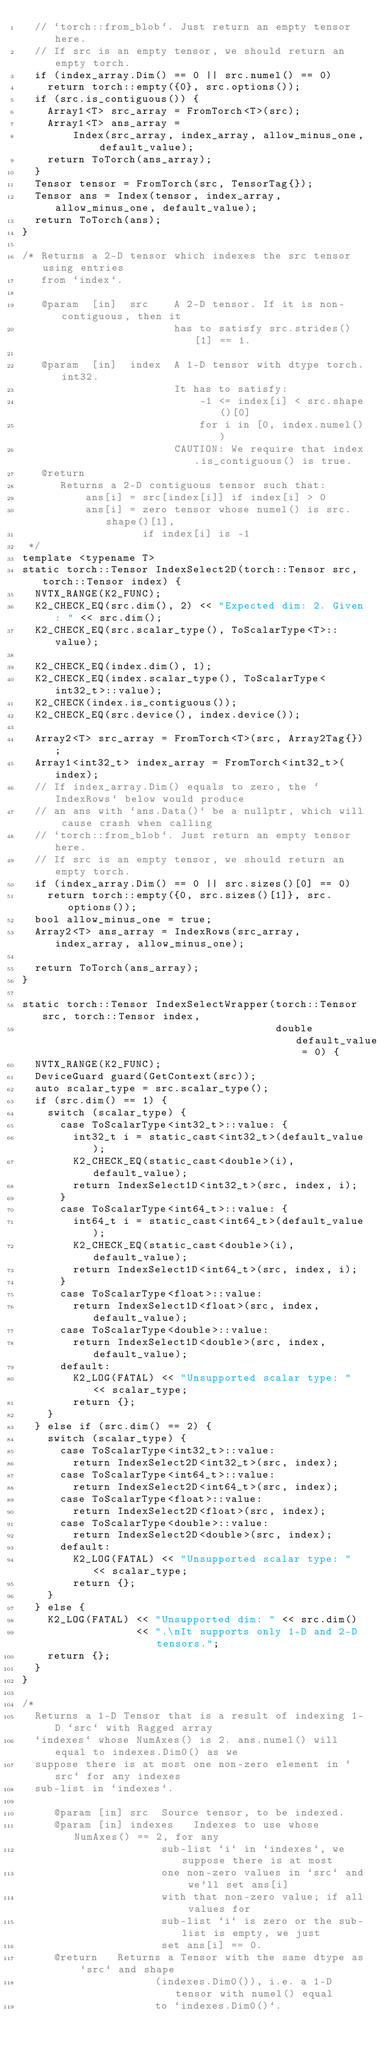Convert code to text. <code><loc_0><loc_0><loc_500><loc_500><_Cuda_>  // `torch::from_blob`. Just return an empty tensor here.
  // If src is an empty tensor, we should return an empty torch.
  if (index_array.Dim() == 0 || src.numel() == 0)
    return torch::empty({0}, src.options());
  if (src.is_contiguous()) {
    Array1<T> src_array = FromTorch<T>(src);
    Array1<T> ans_array =
        Index(src_array, index_array, allow_minus_one, default_value);
    return ToTorch(ans_array);
  }
  Tensor tensor = FromTorch(src, TensorTag{});
  Tensor ans = Index(tensor, index_array, allow_minus_one, default_value);
  return ToTorch(ans);
}

/* Returns a 2-D tensor which indexes the src tensor using entries
   from `index`.

   @param  [in]  src    A 2-D tensor. If it is non-contiguous, then it
                        has to satisfy src.strides()[1] == 1.

   @param  [in]  index  A 1-D tensor with dtype torch.int32.
                        It has to satisfy:
                            -1 <= index[i] < src.shape()[0]
                            for i in [0, index.numel())
                        CAUTION: We require that index.is_contiguous() is true.
   @return
      Returns a 2-D contiguous tensor such that:
          ans[i] = src[index[i]] if index[i] > 0
          ans[i] = zero tensor whose numel() is src.shape()[1],
                   if index[i] is -1
 */
template <typename T>
static torch::Tensor IndexSelect2D(torch::Tensor src, torch::Tensor index) {
  NVTX_RANGE(K2_FUNC);
  K2_CHECK_EQ(src.dim(), 2) << "Expected dim: 2. Given: " << src.dim();
  K2_CHECK_EQ(src.scalar_type(), ToScalarType<T>::value);

  K2_CHECK_EQ(index.dim(), 1);
  K2_CHECK_EQ(index.scalar_type(), ToScalarType<int32_t>::value);
  K2_CHECK(index.is_contiguous());
  K2_CHECK_EQ(src.device(), index.device());

  Array2<T> src_array = FromTorch<T>(src, Array2Tag{});
  Array1<int32_t> index_array = FromTorch<int32_t>(index);
  // If index_array.Dim() equals to zero, the `IndexRows` below would produce
  // an ans with `ans.Data()` be a nullptr, which will cause crash when calling
  // `torch::from_blob`. Just return an empty tensor here.
  // If src is an empty tensor, we should return an empty torch.
  if (index_array.Dim() == 0 || src.sizes()[0] == 0)
    return torch::empty({0, src.sizes()[1]}, src.options());
  bool allow_minus_one = true;
  Array2<T> ans_array = IndexRows(src_array, index_array, allow_minus_one);

  return ToTorch(ans_array);
}

static torch::Tensor IndexSelectWrapper(torch::Tensor src, torch::Tensor index,
                                        double default_value = 0) {
  NVTX_RANGE(K2_FUNC);
  DeviceGuard guard(GetContext(src));
  auto scalar_type = src.scalar_type();
  if (src.dim() == 1) {
    switch (scalar_type) {
      case ToScalarType<int32_t>::value: {
        int32_t i = static_cast<int32_t>(default_value);
        K2_CHECK_EQ(static_cast<double>(i), default_value);
        return IndexSelect1D<int32_t>(src, index, i);
      }
      case ToScalarType<int64_t>::value: {
        int64_t i = static_cast<int64_t>(default_value);
        K2_CHECK_EQ(static_cast<double>(i), default_value);
        return IndexSelect1D<int64_t>(src, index, i);
      }
      case ToScalarType<float>::value:
        return IndexSelect1D<float>(src, index, default_value);
      case ToScalarType<double>::value:
        return IndexSelect1D<double>(src, index, default_value);
      default:
        K2_LOG(FATAL) << "Unsupported scalar type: " << scalar_type;
        return {};
    }
  } else if (src.dim() == 2) {
    switch (scalar_type) {
      case ToScalarType<int32_t>::value:
        return IndexSelect2D<int32_t>(src, index);
      case ToScalarType<int64_t>::value:
        return IndexSelect2D<int64_t>(src, index);
      case ToScalarType<float>::value:
        return IndexSelect2D<float>(src, index);
      case ToScalarType<double>::value:
        return IndexSelect2D<double>(src, index);
      default:
        K2_LOG(FATAL) << "Unsupported scalar type: " << scalar_type;
        return {};
    }
  } else {
    K2_LOG(FATAL) << "Unsupported dim: " << src.dim()
                  << ".\nIt supports only 1-D and 2-D tensors.";
    return {};
  }
}

/*
  Returns a 1-D Tensor that is a result of indexing 1-D `src` with Ragged array
  `indexes` whose NumAxes() is 2. ans.numel() will equal to indexes.Dim0() as we
  suppose there is at most one non-zero element in `src` for any indexes
  sub-list in `indexes`.

     @param [in] src  Source tensor, to be indexed.
     @param [in] indexes   Indexes to use whose NumAxes() == 2, for any
                      sub-list `i` in `indexes`, we suppose there is at most
                      one non-zero values in `src` and we'll set ans[i]
                      with that non-zero value; if all values for
                      sub-list `i` is zero or the sub-list is empty, we just
                      set ans[i] == 0.
     @return   Returns a Tensor with the same dtype as `src` and shape
                     (indexes.Dim0()), i.e. a 1-D tensor with numel() equal
                     to `indexes.Dim0()`.</code> 